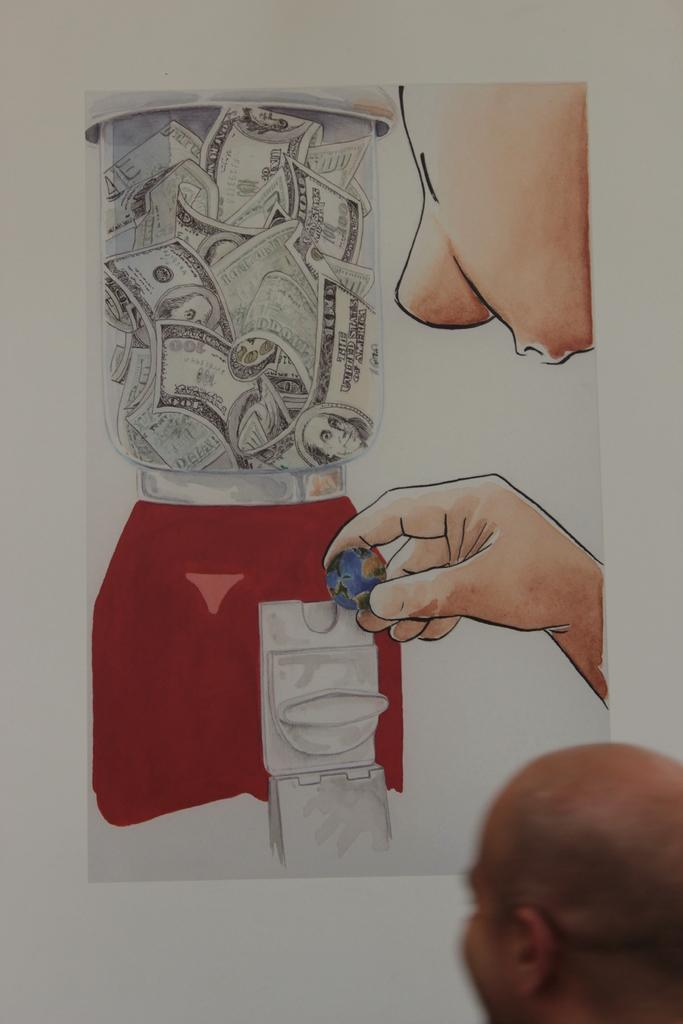What is the main subject of the image? There is a person's head in the image. Can you describe anything in the background of the image? There is a poster on the wall in the background of the image. Is there a river flowing through the person's head in the image? No, there is no river present in the image. 